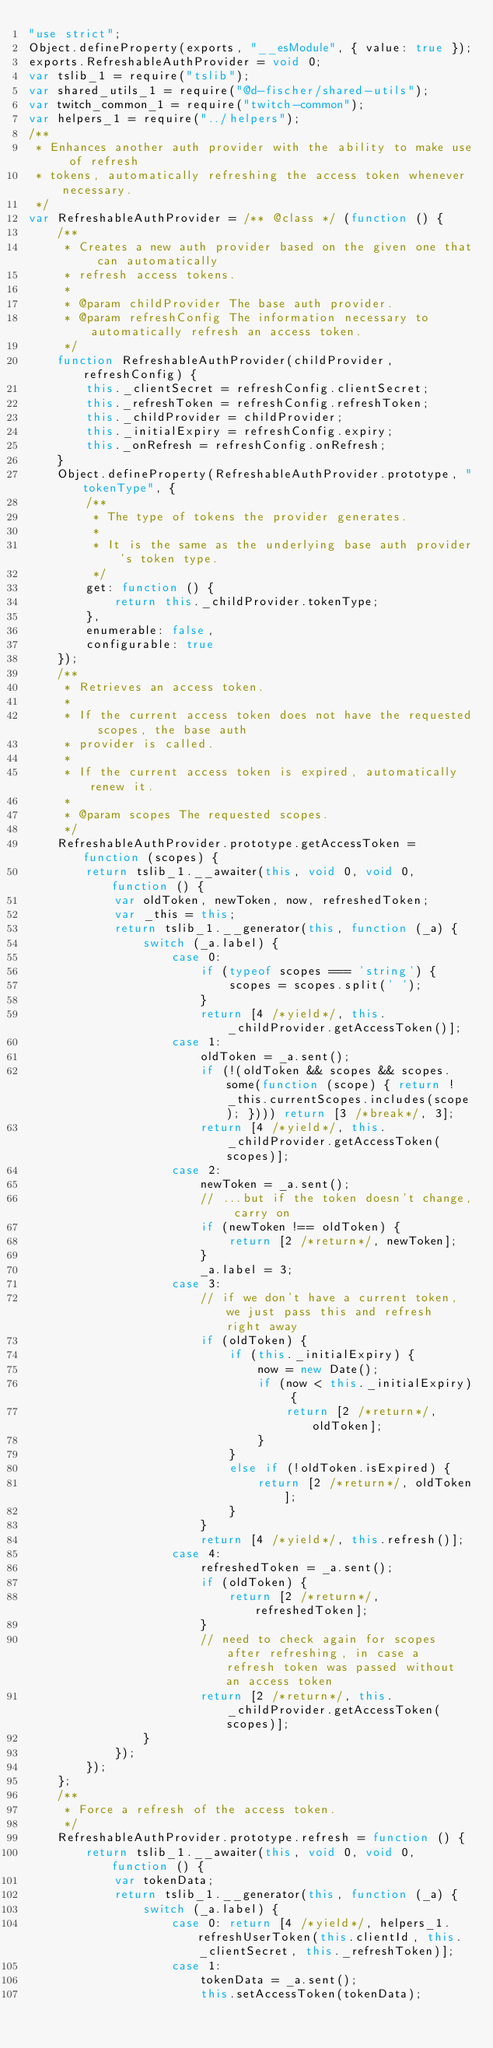Convert code to text. <code><loc_0><loc_0><loc_500><loc_500><_JavaScript_>"use strict";
Object.defineProperty(exports, "__esModule", { value: true });
exports.RefreshableAuthProvider = void 0;
var tslib_1 = require("tslib");
var shared_utils_1 = require("@d-fischer/shared-utils");
var twitch_common_1 = require("twitch-common");
var helpers_1 = require("../helpers");
/**
 * Enhances another auth provider with the ability to make use of refresh
 * tokens, automatically refreshing the access token whenever necessary.
 */
var RefreshableAuthProvider = /** @class */ (function () {
    /**
     * Creates a new auth provider based on the given one that can automatically
     * refresh access tokens.
     *
     * @param childProvider The base auth provider.
     * @param refreshConfig The information necessary to automatically refresh an access token.
     */
    function RefreshableAuthProvider(childProvider, refreshConfig) {
        this._clientSecret = refreshConfig.clientSecret;
        this._refreshToken = refreshConfig.refreshToken;
        this._childProvider = childProvider;
        this._initialExpiry = refreshConfig.expiry;
        this._onRefresh = refreshConfig.onRefresh;
    }
    Object.defineProperty(RefreshableAuthProvider.prototype, "tokenType", {
        /**
         * The type of tokens the provider generates.
         *
         * It is the same as the underlying base auth provider's token type.
         */
        get: function () {
            return this._childProvider.tokenType;
        },
        enumerable: false,
        configurable: true
    });
    /**
     * Retrieves an access token.
     *
     * If the current access token does not have the requested scopes, the base auth
     * provider is called.
     *
     * If the current access token is expired, automatically renew it.
     *
     * @param scopes The requested scopes.
     */
    RefreshableAuthProvider.prototype.getAccessToken = function (scopes) {
        return tslib_1.__awaiter(this, void 0, void 0, function () {
            var oldToken, newToken, now, refreshedToken;
            var _this = this;
            return tslib_1.__generator(this, function (_a) {
                switch (_a.label) {
                    case 0:
                        if (typeof scopes === 'string') {
                            scopes = scopes.split(' ');
                        }
                        return [4 /*yield*/, this._childProvider.getAccessToken()];
                    case 1:
                        oldToken = _a.sent();
                        if (!(oldToken && scopes && scopes.some(function (scope) { return !_this.currentScopes.includes(scope); }))) return [3 /*break*/, 3];
                        return [4 /*yield*/, this._childProvider.getAccessToken(scopes)];
                    case 2:
                        newToken = _a.sent();
                        // ...but if the token doesn't change, carry on
                        if (newToken !== oldToken) {
                            return [2 /*return*/, newToken];
                        }
                        _a.label = 3;
                    case 3:
                        // if we don't have a current token, we just pass this and refresh right away
                        if (oldToken) {
                            if (this._initialExpiry) {
                                now = new Date();
                                if (now < this._initialExpiry) {
                                    return [2 /*return*/, oldToken];
                                }
                            }
                            else if (!oldToken.isExpired) {
                                return [2 /*return*/, oldToken];
                            }
                        }
                        return [4 /*yield*/, this.refresh()];
                    case 4:
                        refreshedToken = _a.sent();
                        if (oldToken) {
                            return [2 /*return*/, refreshedToken];
                        }
                        // need to check again for scopes after refreshing, in case a refresh token was passed without an access token
                        return [2 /*return*/, this._childProvider.getAccessToken(scopes)];
                }
            });
        });
    };
    /**
     * Force a refresh of the access token.
     */
    RefreshableAuthProvider.prototype.refresh = function () {
        return tslib_1.__awaiter(this, void 0, void 0, function () {
            var tokenData;
            return tslib_1.__generator(this, function (_a) {
                switch (_a.label) {
                    case 0: return [4 /*yield*/, helpers_1.refreshUserToken(this.clientId, this._clientSecret, this._refreshToken)];
                    case 1:
                        tokenData = _a.sent();
                        this.setAccessToken(tokenData);</code> 